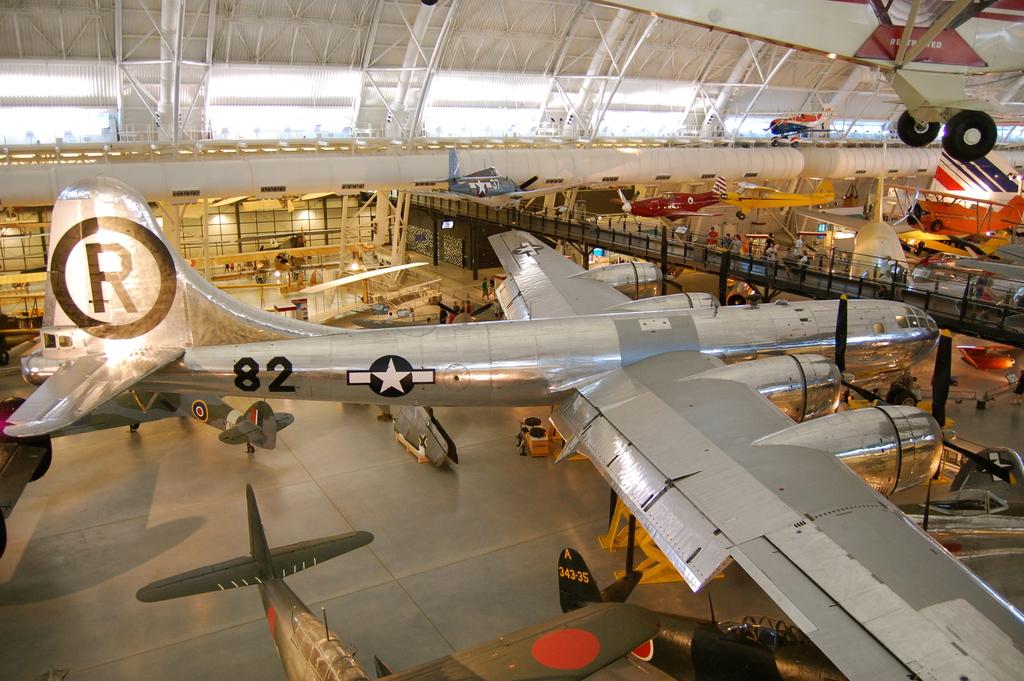What identification number belongs to the big bomber plane in the center?
Make the answer very short. 82. What letter is in the black circle?
Give a very brief answer. R. 